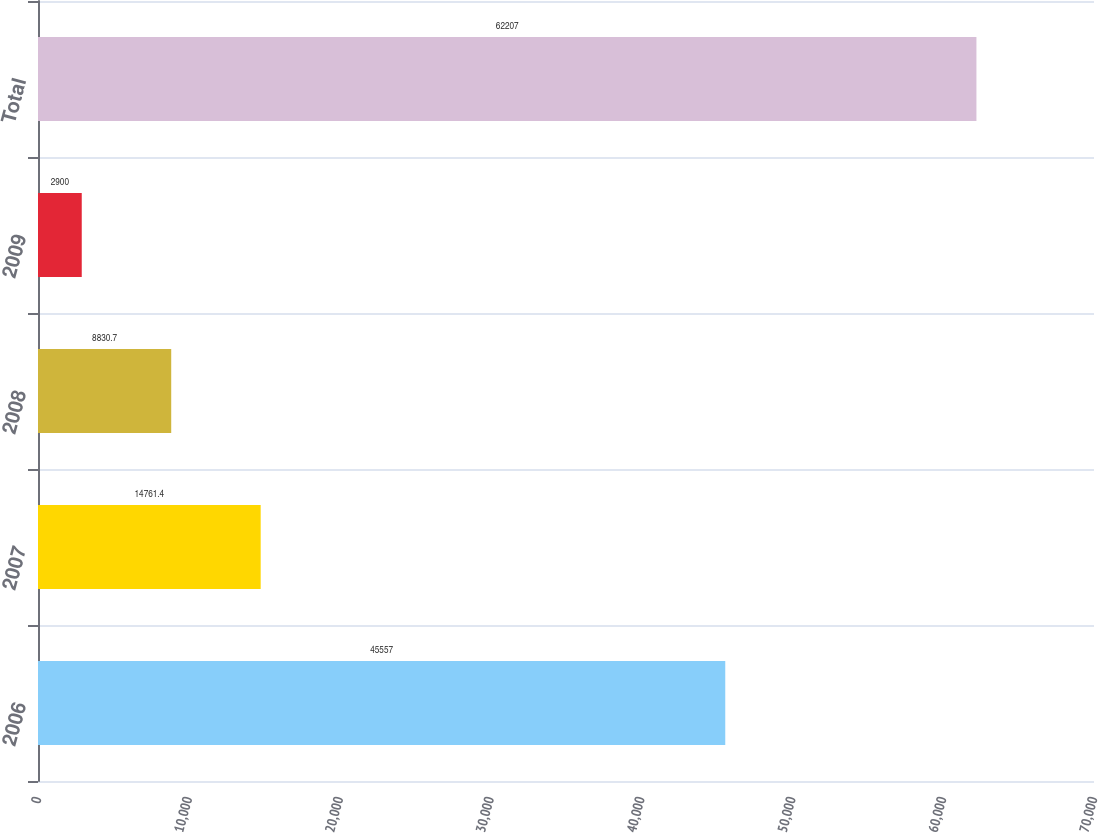Convert chart to OTSL. <chart><loc_0><loc_0><loc_500><loc_500><bar_chart><fcel>2006<fcel>2007<fcel>2008<fcel>2009<fcel>Total<nl><fcel>45557<fcel>14761.4<fcel>8830.7<fcel>2900<fcel>62207<nl></chart> 